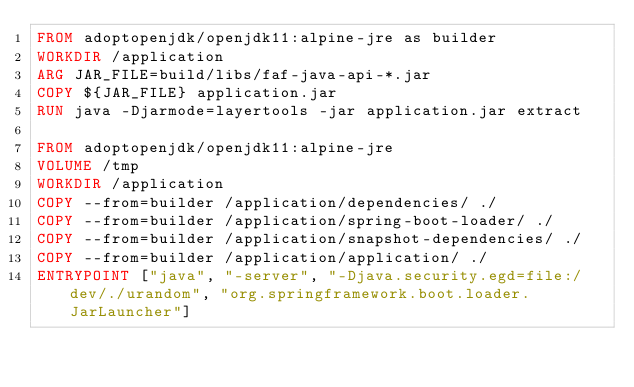<code> <loc_0><loc_0><loc_500><loc_500><_Dockerfile_>FROM adoptopenjdk/openjdk11:alpine-jre as builder
WORKDIR /application
ARG JAR_FILE=build/libs/faf-java-api-*.jar
COPY ${JAR_FILE} application.jar
RUN java -Djarmode=layertools -jar application.jar extract

FROM adoptopenjdk/openjdk11:alpine-jre
VOLUME /tmp
WORKDIR /application
COPY --from=builder /application/dependencies/ ./
COPY --from=builder /application/spring-boot-loader/ ./
COPY --from=builder /application/snapshot-dependencies/ ./
COPY --from=builder /application/application/ ./
ENTRYPOINT ["java", "-server", "-Djava.security.egd=file:/dev/./urandom", "org.springframework.boot.loader.JarLauncher"]
</code> 